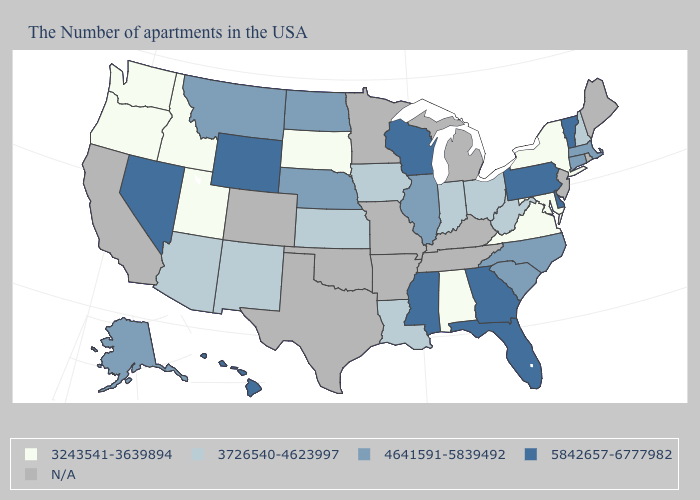Does Kansas have the highest value in the MidWest?
Keep it brief. No. What is the value of Illinois?
Be succinct. 4641591-5839492. What is the value of New Hampshire?
Be succinct. 3726540-4623997. Among the states that border North Carolina , which have the lowest value?
Quick response, please. Virginia. What is the lowest value in the Northeast?
Keep it brief. 3243541-3639894. Which states have the highest value in the USA?
Concise answer only. Vermont, Delaware, Pennsylvania, Florida, Georgia, Wisconsin, Mississippi, Wyoming, Nevada, Hawaii. Does Wisconsin have the highest value in the MidWest?
Be succinct. Yes. What is the value of Mississippi?
Quick response, please. 5842657-6777982. Among the states that border New York , which have the lowest value?
Give a very brief answer. Massachusetts, Connecticut. Name the states that have a value in the range 5842657-6777982?
Keep it brief. Vermont, Delaware, Pennsylvania, Florida, Georgia, Wisconsin, Mississippi, Wyoming, Nevada, Hawaii. What is the value of Florida?
Give a very brief answer. 5842657-6777982. Is the legend a continuous bar?
Be succinct. No. Does the map have missing data?
Be succinct. Yes. Name the states that have a value in the range 5842657-6777982?
Be succinct. Vermont, Delaware, Pennsylvania, Florida, Georgia, Wisconsin, Mississippi, Wyoming, Nevada, Hawaii. 